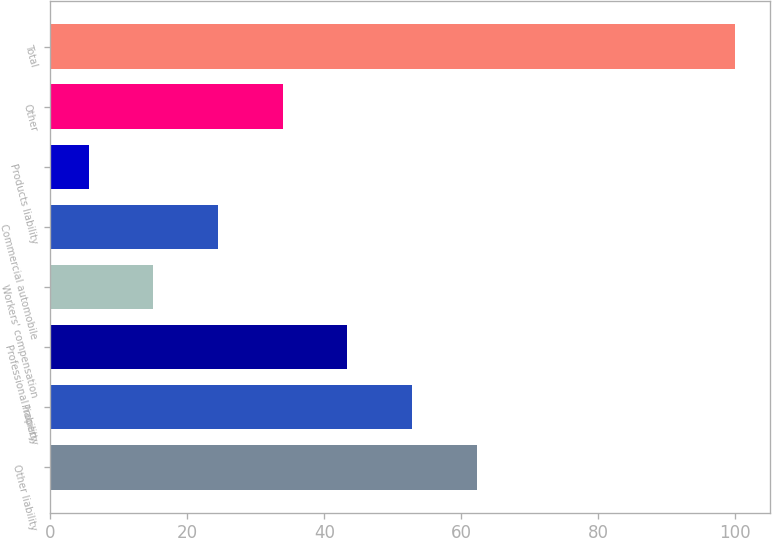Convert chart. <chart><loc_0><loc_0><loc_500><loc_500><bar_chart><fcel>Other liability<fcel>Property<fcel>Professional liability<fcel>Workers' compensation<fcel>Commercial automobile<fcel>Products liability<fcel>Other<fcel>Total<nl><fcel>62.24<fcel>52.8<fcel>43.36<fcel>15.04<fcel>24.48<fcel>5.6<fcel>33.92<fcel>100<nl></chart> 